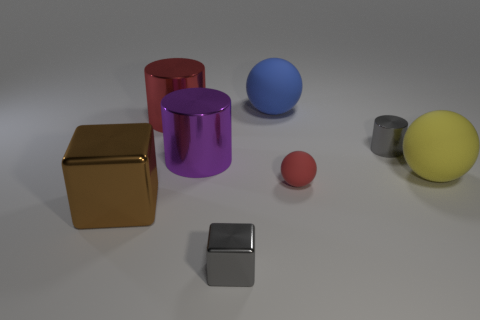Do the tiny metal object that is on the left side of the big blue matte object and the rubber sphere behind the yellow object have the same color?
Provide a short and direct response. No. There is a red rubber object; how many small gray things are on the left side of it?
Provide a short and direct response. 1. What is the material of the thing that is the same color as the tiny cylinder?
Your response must be concise. Metal. Is there a red thing of the same shape as the blue rubber object?
Keep it short and to the point. Yes. Is the material of the cylinder that is on the right side of the gray block the same as the big thing on the right side of the blue object?
Provide a short and direct response. No. There is a object that is in front of the metal block behind the thing that is in front of the large block; what is its size?
Keep it short and to the point. Small. What material is the purple object that is the same size as the yellow rubber object?
Your answer should be very brief. Metal. Is there a green rubber sphere that has the same size as the brown metal object?
Provide a short and direct response. No. Does the small red rubber thing have the same shape as the big purple shiny object?
Keep it short and to the point. No. There is a gray thing behind the big matte thing that is in front of the purple metal cylinder; are there any large blocks right of it?
Give a very brief answer. No. 